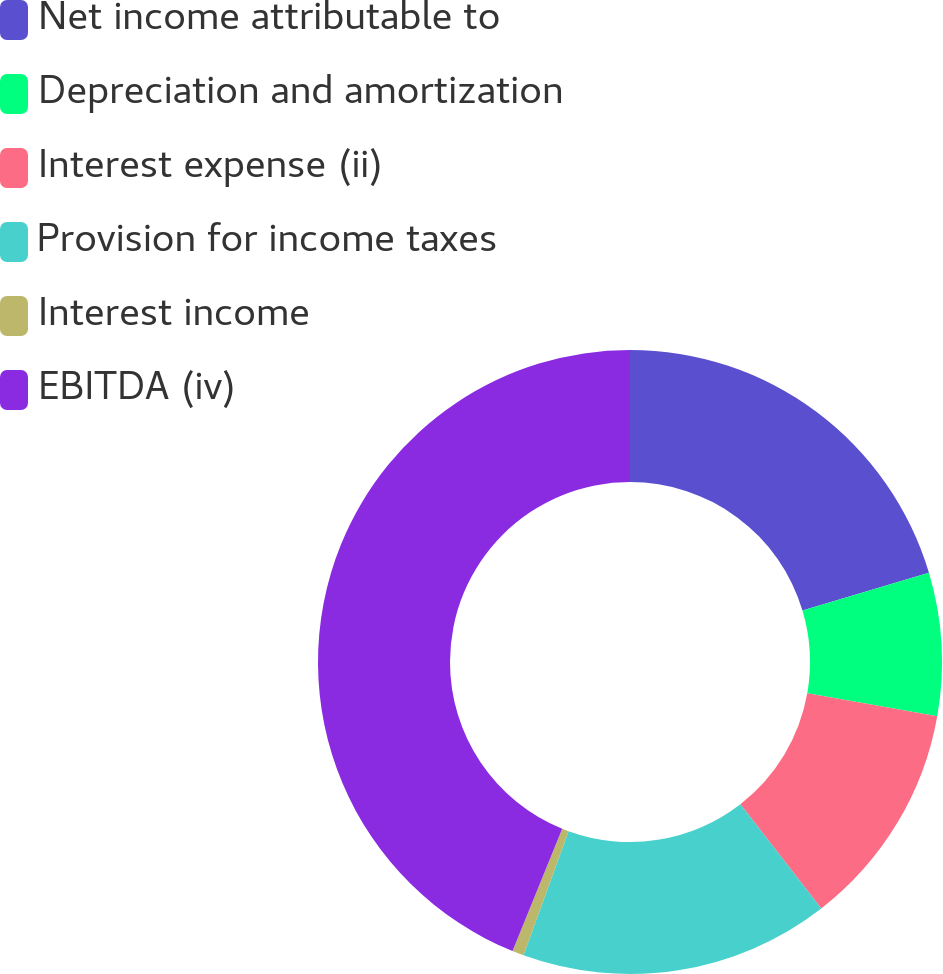Convert chart. <chart><loc_0><loc_0><loc_500><loc_500><pie_chart><fcel>Net income attributable to<fcel>Depreciation and amortization<fcel>Interest expense (ii)<fcel>Provision for income taxes<fcel>Interest income<fcel>EBITDA (iv)<nl><fcel>20.38%<fcel>7.4%<fcel>11.72%<fcel>16.05%<fcel>0.6%<fcel>43.86%<nl></chart> 